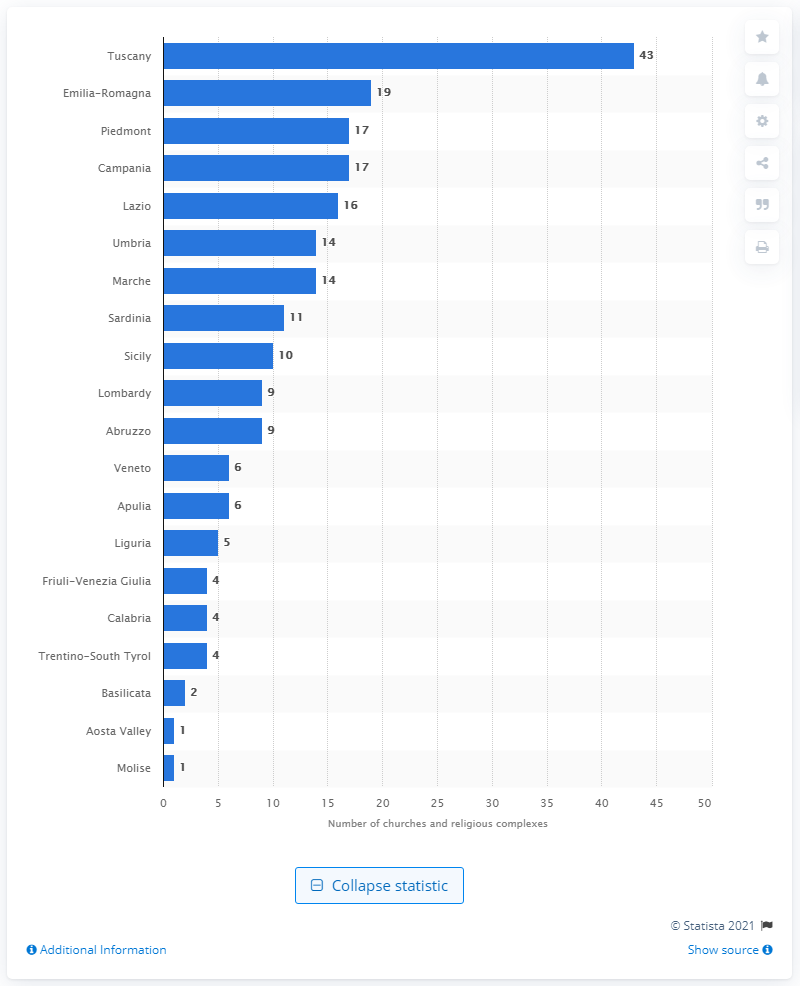Outline some significant characteristics in this image. Tuscany had the highest number of facilities out of all the regions. There were 43 registered churches and religious complexes in Tuscany in 2019. In 2019, Emilia-Romagna region of Italy had the highest number of churches and religious complexes. 